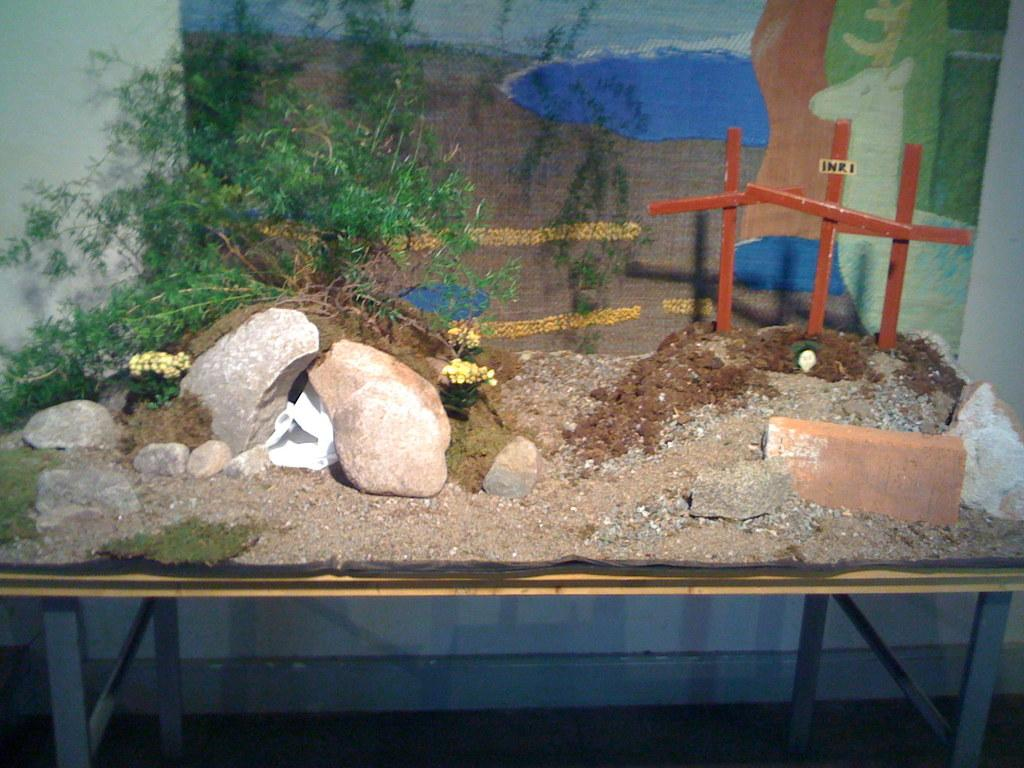What type of furniture is present in the image? There is a table in the image. Where is the table located in relation to the wall? The table is in front of a wall in the image. What materials can be found on the table? The table contains sand, bricks, rocks, sticks, and a plant. What is the profit generated by the table in the image? There is no mention of profit in the image, as it features a table with various materials and not a business or financial transaction. 